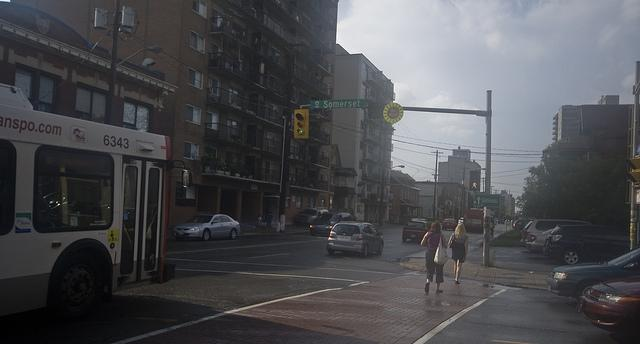Why is the street shiny? just rained 